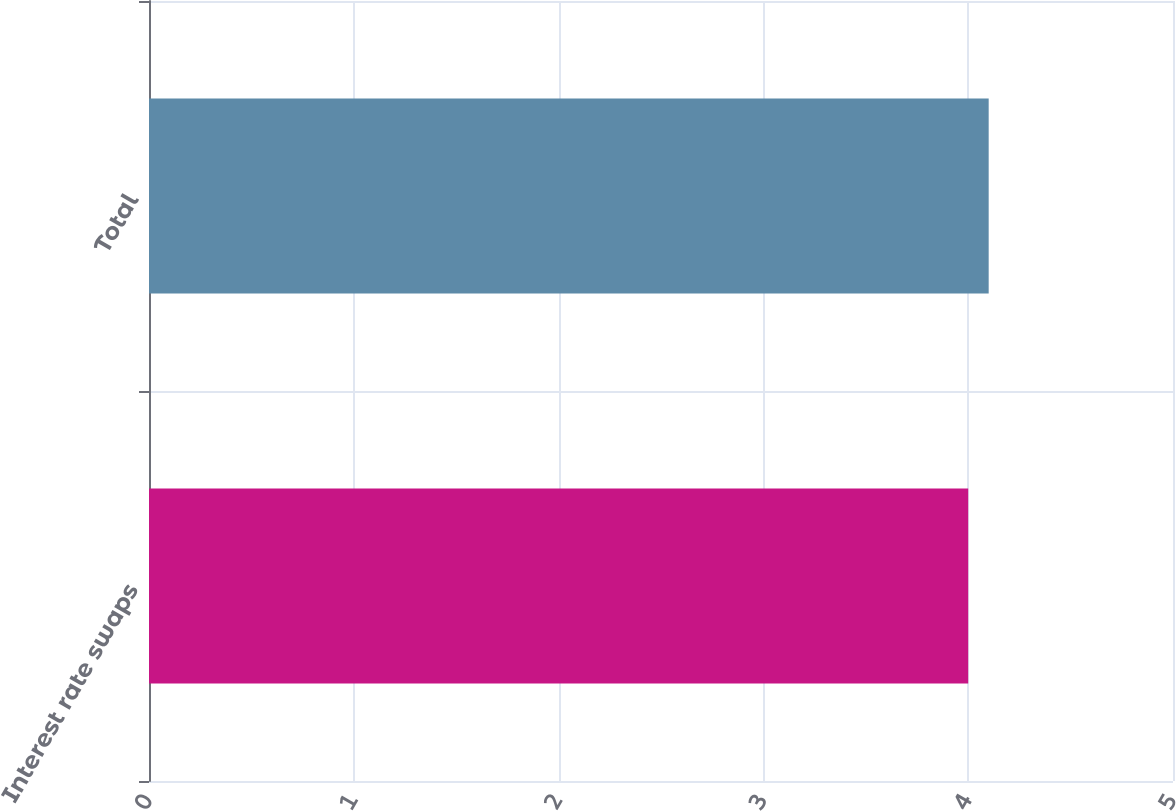<chart> <loc_0><loc_0><loc_500><loc_500><bar_chart><fcel>Interest rate swaps<fcel>Total<nl><fcel>4<fcel>4.1<nl></chart> 